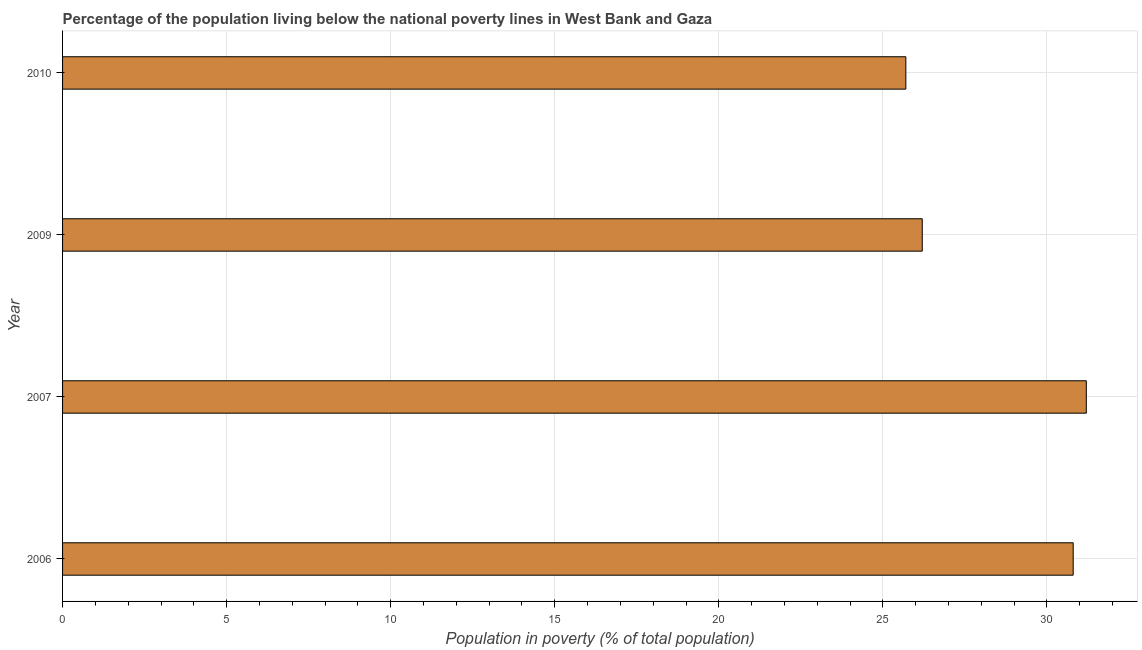What is the title of the graph?
Make the answer very short. Percentage of the population living below the national poverty lines in West Bank and Gaza. What is the label or title of the X-axis?
Offer a very short reply. Population in poverty (% of total population). What is the label or title of the Y-axis?
Your answer should be compact. Year. What is the percentage of population living below poverty line in 2007?
Keep it short and to the point. 31.2. Across all years, what is the maximum percentage of population living below poverty line?
Provide a short and direct response. 31.2. Across all years, what is the minimum percentage of population living below poverty line?
Your answer should be compact. 25.7. What is the sum of the percentage of population living below poverty line?
Give a very brief answer. 113.9. What is the difference between the percentage of population living below poverty line in 2006 and 2009?
Your answer should be very brief. 4.6. What is the average percentage of population living below poverty line per year?
Provide a short and direct response. 28.48. In how many years, is the percentage of population living below poverty line greater than 5 %?
Keep it short and to the point. 4. What is the ratio of the percentage of population living below poverty line in 2007 to that in 2009?
Offer a terse response. 1.19. Is the percentage of population living below poverty line in 2006 less than that in 2009?
Ensure brevity in your answer.  No. What is the difference between the highest and the second highest percentage of population living below poverty line?
Offer a very short reply. 0.4. Is the sum of the percentage of population living below poverty line in 2006 and 2007 greater than the maximum percentage of population living below poverty line across all years?
Your answer should be very brief. Yes. What is the difference between the highest and the lowest percentage of population living below poverty line?
Your answer should be compact. 5.5. In how many years, is the percentage of population living below poverty line greater than the average percentage of population living below poverty line taken over all years?
Provide a succinct answer. 2. How many bars are there?
Your answer should be very brief. 4. Are all the bars in the graph horizontal?
Offer a terse response. Yes. What is the Population in poverty (% of total population) in 2006?
Make the answer very short. 30.8. What is the Population in poverty (% of total population) in 2007?
Give a very brief answer. 31.2. What is the Population in poverty (% of total population) of 2009?
Make the answer very short. 26.2. What is the Population in poverty (% of total population) in 2010?
Offer a terse response. 25.7. What is the difference between the Population in poverty (% of total population) in 2009 and 2010?
Your response must be concise. 0.5. What is the ratio of the Population in poverty (% of total population) in 2006 to that in 2007?
Provide a short and direct response. 0.99. What is the ratio of the Population in poverty (% of total population) in 2006 to that in 2009?
Keep it short and to the point. 1.18. What is the ratio of the Population in poverty (% of total population) in 2006 to that in 2010?
Offer a very short reply. 1.2. What is the ratio of the Population in poverty (% of total population) in 2007 to that in 2009?
Your response must be concise. 1.19. What is the ratio of the Population in poverty (% of total population) in 2007 to that in 2010?
Give a very brief answer. 1.21. 